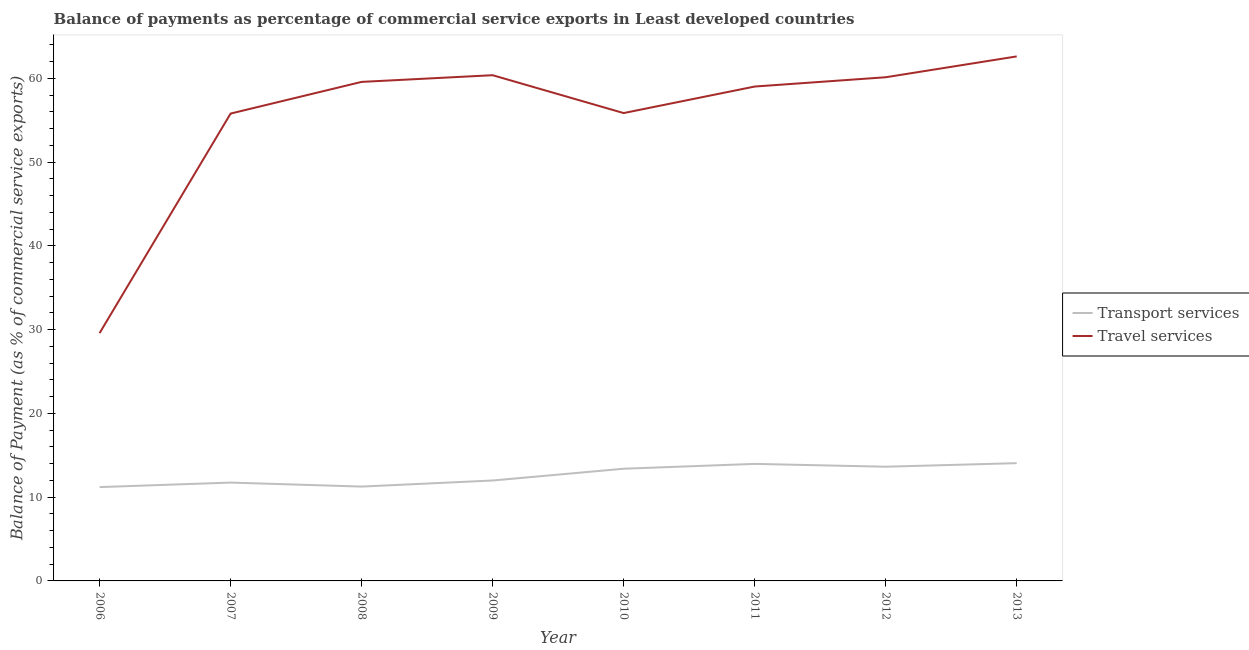Does the line corresponding to balance of payments of travel services intersect with the line corresponding to balance of payments of transport services?
Provide a short and direct response. No. Is the number of lines equal to the number of legend labels?
Your response must be concise. Yes. What is the balance of payments of transport services in 2006?
Offer a terse response. 11.2. Across all years, what is the maximum balance of payments of travel services?
Your response must be concise. 62.62. Across all years, what is the minimum balance of payments of transport services?
Make the answer very short. 11.2. In which year was the balance of payments of transport services maximum?
Provide a succinct answer. 2013. In which year was the balance of payments of transport services minimum?
Your response must be concise. 2006. What is the total balance of payments of travel services in the graph?
Provide a succinct answer. 442.94. What is the difference between the balance of payments of transport services in 2007 and that in 2012?
Provide a succinct answer. -1.89. What is the difference between the balance of payments of travel services in 2013 and the balance of payments of transport services in 2008?
Provide a short and direct response. 51.35. What is the average balance of payments of travel services per year?
Offer a very short reply. 55.37. In the year 2013, what is the difference between the balance of payments of transport services and balance of payments of travel services?
Keep it short and to the point. -48.56. In how many years, is the balance of payments of travel services greater than 8 %?
Ensure brevity in your answer.  8. What is the ratio of the balance of payments of travel services in 2006 to that in 2007?
Offer a terse response. 0.53. What is the difference between the highest and the second highest balance of payments of transport services?
Your answer should be very brief. 0.09. What is the difference between the highest and the lowest balance of payments of travel services?
Your answer should be very brief. 33.03. Is the balance of payments of transport services strictly greater than the balance of payments of travel services over the years?
Provide a short and direct response. No. What is the difference between two consecutive major ticks on the Y-axis?
Offer a terse response. 10. How many legend labels are there?
Offer a terse response. 2. How are the legend labels stacked?
Offer a very short reply. Vertical. What is the title of the graph?
Provide a short and direct response. Balance of payments as percentage of commercial service exports in Least developed countries. Does "% of gross capital formation" appear as one of the legend labels in the graph?
Ensure brevity in your answer.  No. What is the label or title of the X-axis?
Give a very brief answer. Year. What is the label or title of the Y-axis?
Provide a short and direct response. Balance of Payment (as % of commercial service exports). What is the Balance of Payment (as % of commercial service exports) of Transport services in 2006?
Give a very brief answer. 11.2. What is the Balance of Payment (as % of commercial service exports) of Travel services in 2006?
Your answer should be very brief. 29.58. What is the Balance of Payment (as % of commercial service exports) of Transport services in 2007?
Provide a succinct answer. 11.74. What is the Balance of Payment (as % of commercial service exports) in Travel services in 2007?
Your answer should be very brief. 55.79. What is the Balance of Payment (as % of commercial service exports) of Transport services in 2008?
Provide a short and direct response. 11.26. What is the Balance of Payment (as % of commercial service exports) of Travel services in 2008?
Offer a terse response. 59.57. What is the Balance of Payment (as % of commercial service exports) of Transport services in 2009?
Offer a very short reply. 11.99. What is the Balance of Payment (as % of commercial service exports) of Travel services in 2009?
Your response must be concise. 60.37. What is the Balance of Payment (as % of commercial service exports) in Transport services in 2010?
Provide a succinct answer. 13.39. What is the Balance of Payment (as % of commercial service exports) of Travel services in 2010?
Your response must be concise. 55.85. What is the Balance of Payment (as % of commercial service exports) in Transport services in 2011?
Your answer should be very brief. 13.97. What is the Balance of Payment (as % of commercial service exports) in Travel services in 2011?
Offer a terse response. 59.02. What is the Balance of Payment (as % of commercial service exports) of Transport services in 2012?
Your answer should be compact. 13.63. What is the Balance of Payment (as % of commercial service exports) of Travel services in 2012?
Give a very brief answer. 60.13. What is the Balance of Payment (as % of commercial service exports) in Transport services in 2013?
Give a very brief answer. 14.06. What is the Balance of Payment (as % of commercial service exports) in Travel services in 2013?
Ensure brevity in your answer.  62.62. Across all years, what is the maximum Balance of Payment (as % of commercial service exports) in Transport services?
Make the answer very short. 14.06. Across all years, what is the maximum Balance of Payment (as % of commercial service exports) in Travel services?
Make the answer very short. 62.62. Across all years, what is the minimum Balance of Payment (as % of commercial service exports) of Transport services?
Give a very brief answer. 11.2. Across all years, what is the minimum Balance of Payment (as % of commercial service exports) of Travel services?
Your answer should be very brief. 29.58. What is the total Balance of Payment (as % of commercial service exports) of Transport services in the graph?
Keep it short and to the point. 101.25. What is the total Balance of Payment (as % of commercial service exports) of Travel services in the graph?
Give a very brief answer. 442.94. What is the difference between the Balance of Payment (as % of commercial service exports) of Transport services in 2006 and that in 2007?
Keep it short and to the point. -0.54. What is the difference between the Balance of Payment (as % of commercial service exports) of Travel services in 2006 and that in 2007?
Ensure brevity in your answer.  -26.21. What is the difference between the Balance of Payment (as % of commercial service exports) of Transport services in 2006 and that in 2008?
Your answer should be very brief. -0.06. What is the difference between the Balance of Payment (as % of commercial service exports) of Travel services in 2006 and that in 2008?
Keep it short and to the point. -29.99. What is the difference between the Balance of Payment (as % of commercial service exports) in Transport services in 2006 and that in 2009?
Keep it short and to the point. -0.79. What is the difference between the Balance of Payment (as % of commercial service exports) in Travel services in 2006 and that in 2009?
Provide a short and direct response. -30.79. What is the difference between the Balance of Payment (as % of commercial service exports) of Transport services in 2006 and that in 2010?
Keep it short and to the point. -2.19. What is the difference between the Balance of Payment (as % of commercial service exports) in Travel services in 2006 and that in 2010?
Ensure brevity in your answer.  -26.27. What is the difference between the Balance of Payment (as % of commercial service exports) in Transport services in 2006 and that in 2011?
Provide a succinct answer. -2.77. What is the difference between the Balance of Payment (as % of commercial service exports) in Travel services in 2006 and that in 2011?
Provide a short and direct response. -29.44. What is the difference between the Balance of Payment (as % of commercial service exports) of Transport services in 2006 and that in 2012?
Ensure brevity in your answer.  -2.43. What is the difference between the Balance of Payment (as % of commercial service exports) in Travel services in 2006 and that in 2012?
Offer a very short reply. -30.55. What is the difference between the Balance of Payment (as % of commercial service exports) in Transport services in 2006 and that in 2013?
Your answer should be very brief. -2.86. What is the difference between the Balance of Payment (as % of commercial service exports) of Travel services in 2006 and that in 2013?
Give a very brief answer. -33.03. What is the difference between the Balance of Payment (as % of commercial service exports) in Transport services in 2007 and that in 2008?
Offer a very short reply. 0.48. What is the difference between the Balance of Payment (as % of commercial service exports) of Travel services in 2007 and that in 2008?
Provide a short and direct response. -3.78. What is the difference between the Balance of Payment (as % of commercial service exports) in Transport services in 2007 and that in 2009?
Your answer should be very brief. -0.25. What is the difference between the Balance of Payment (as % of commercial service exports) in Travel services in 2007 and that in 2009?
Offer a terse response. -4.58. What is the difference between the Balance of Payment (as % of commercial service exports) in Transport services in 2007 and that in 2010?
Provide a short and direct response. -1.65. What is the difference between the Balance of Payment (as % of commercial service exports) in Travel services in 2007 and that in 2010?
Offer a terse response. -0.06. What is the difference between the Balance of Payment (as % of commercial service exports) of Transport services in 2007 and that in 2011?
Make the answer very short. -2.23. What is the difference between the Balance of Payment (as % of commercial service exports) in Travel services in 2007 and that in 2011?
Ensure brevity in your answer.  -3.23. What is the difference between the Balance of Payment (as % of commercial service exports) of Transport services in 2007 and that in 2012?
Offer a very short reply. -1.89. What is the difference between the Balance of Payment (as % of commercial service exports) of Travel services in 2007 and that in 2012?
Give a very brief answer. -4.34. What is the difference between the Balance of Payment (as % of commercial service exports) in Transport services in 2007 and that in 2013?
Keep it short and to the point. -2.32. What is the difference between the Balance of Payment (as % of commercial service exports) in Travel services in 2007 and that in 2013?
Your answer should be compact. -6.82. What is the difference between the Balance of Payment (as % of commercial service exports) of Transport services in 2008 and that in 2009?
Make the answer very short. -0.73. What is the difference between the Balance of Payment (as % of commercial service exports) of Travel services in 2008 and that in 2009?
Keep it short and to the point. -0.8. What is the difference between the Balance of Payment (as % of commercial service exports) in Transport services in 2008 and that in 2010?
Keep it short and to the point. -2.13. What is the difference between the Balance of Payment (as % of commercial service exports) of Travel services in 2008 and that in 2010?
Offer a very short reply. 3.72. What is the difference between the Balance of Payment (as % of commercial service exports) in Transport services in 2008 and that in 2011?
Keep it short and to the point. -2.71. What is the difference between the Balance of Payment (as % of commercial service exports) of Travel services in 2008 and that in 2011?
Keep it short and to the point. 0.55. What is the difference between the Balance of Payment (as % of commercial service exports) of Transport services in 2008 and that in 2012?
Provide a short and direct response. -2.37. What is the difference between the Balance of Payment (as % of commercial service exports) of Travel services in 2008 and that in 2012?
Your response must be concise. -0.55. What is the difference between the Balance of Payment (as % of commercial service exports) in Transport services in 2008 and that in 2013?
Your response must be concise. -2.8. What is the difference between the Balance of Payment (as % of commercial service exports) in Travel services in 2008 and that in 2013?
Provide a succinct answer. -3.04. What is the difference between the Balance of Payment (as % of commercial service exports) of Transport services in 2009 and that in 2010?
Ensure brevity in your answer.  -1.41. What is the difference between the Balance of Payment (as % of commercial service exports) in Travel services in 2009 and that in 2010?
Offer a very short reply. 4.52. What is the difference between the Balance of Payment (as % of commercial service exports) in Transport services in 2009 and that in 2011?
Offer a terse response. -1.98. What is the difference between the Balance of Payment (as % of commercial service exports) in Travel services in 2009 and that in 2011?
Ensure brevity in your answer.  1.35. What is the difference between the Balance of Payment (as % of commercial service exports) in Transport services in 2009 and that in 2012?
Your answer should be compact. -1.65. What is the difference between the Balance of Payment (as % of commercial service exports) of Travel services in 2009 and that in 2012?
Your response must be concise. 0.24. What is the difference between the Balance of Payment (as % of commercial service exports) of Transport services in 2009 and that in 2013?
Offer a very short reply. -2.07. What is the difference between the Balance of Payment (as % of commercial service exports) in Travel services in 2009 and that in 2013?
Your answer should be compact. -2.24. What is the difference between the Balance of Payment (as % of commercial service exports) in Transport services in 2010 and that in 2011?
Keep it short and to the point. -0.58. What is the difference between the Balance of Payment (as % of commercial service exports) in Travel services in 2010 and that in 2011?
Your answer should be compact. -3.17. What is the difference between the Balance of Payment (as % of commercial service exports) of Transport services in 2010 and that in 2012?
Provide a short and direct response. -0.24. What is the difference between the Balance of Payment (as % of commercial service exports) in Travel services in 2010 and that in 2012?
Give a very brief answer. -4.28. What is the difference between the Balance of Payment (as % of commercial service exports) of Transport services in 2010 and that in 2013?
Your answer should be compact. -0.66. What is the difference between the Balance of Payment (as % of commercial service exports) of Travel services in 2010 and that in 2013?
Your answer should be very brief. -6.76. What is the difference between the Balance of Payment (as % of commercial service exports) of Transport services in 2011 and that in 2012?
Ensure brevity in your answer.  0.34. What is the difference between the Balance of Payment (as % of commercial service exports) of Travel services in 2011 and that in 2012?
Make the answer very short. -1.11. What is the difference between the Balance of Payment (as % of commercial service exports) in Transport services in 2011 and that in 2013?
Your answer should be compact. -0.09. What is the difference between the Balance of Payment (as % of commercial service exports) of Travel services in 2011 and that in 2013?
Offer a terse response. -3.6. What is the difference between the Balance of Payment (as % of commercial service exports) of Transport services in 2012 and that in 2013?
Give a very brief answer. -0.42. What is the difference between the Balance of Payment (as % of commercial service exports) in Travel services in 2012 and that in 2013?
Keep it short and to the point. -2.49. What is the difference between the Balance of Payment (as % of commercial service exports) in Transport services in 2006 and the Balance of Payment (as % of commercial service exports) in Travel services in 2007?
Your response must be concise. -44.59. What is the difference between the Balance of Payment (as % of commercial service exports) of Transport services in 2006 and the Balance of Payment (as % of commercial service exports) of Travel services in 2008?
Offer a very short reply. -48.37. What is the difference between the Balance of Payment (as % of commercial service exports) in Transport services in 2006 and the Balance of Payment (as % of commercial service exports) in Travel services in 2009?
Your answer should be compact. -49.17. What is the difference between the Balance of Payment (as % of commercial service exports) of Transport services in 2006 and the Balance of Payment (as % of commercial service exports) of Travel services in 2010?
Your answer should be very brief. -44.65. What is the difference between the Balance of Payment (as % of commercial service exports) in Transport services in 2006 and the Balance of Payment (as % of commercial service exports) in Travel services in 2011?
Your answer should be very brief. -47.82. What is the difference between the Balance of Payment (as % of commercial service exports) of Transport services in 2006 and the Balance of Payment (as % of commercial service exports) of Travel services in 2012?
Your response must be concise. -48.93. What is the difference between the Balance of Payment (as % of commercial service exports) of Transport services in 2006 and the Balance of Payment (as % of commercial service exports) of Travel services in 2013?
Provide a succinct answer. -51.42. What is the difference between the Balance of Payment (as % of commercial service exports) of Transport services in 2007 and the Balance of Payment (as % of commercial service exports) of Travel services in 2008?
Your answer should be compact. -47.83. What is the difference between the Balance of Payment (as % of commercial service exports) in Transport services in 2007 and the Balance of Payment (as % of commercial service exports) in Travel services in 2009?
Ensure brevity in your answer.  -48.63. What is the difference between the Balance of Payment (as % of commercial service exports) of Transport services in 2007 and the Balance of Payment (as % of commercial service exports) of Travel services in 2010?
Offer a very short reply. -44.11. What is the difference between the Balance of Payment (as % of commercial service exports) in Transport services in 2007 and the Balance of Payment (as % of commercial service exports) in Travel services in 2011?
Your answer should be very brief. -47.28. What is the difference between the Balance of Payment (as % of commercial service exports) of Transport services in 2007 and the Balance of Payment (as % of commercial service exports) of Travel services in 2012?
Your answer should be very brief. -48.39. What is the difference between the Balance of Payment (as % of commercial service exports) of Transport services in 2007 and the Balance of Payment (as % of commercial service exports) of Travel services in 2013?
Ensure brevity in your answer.  -50.88. What is the difference between the Balance of Payment (as % of commercial service exports) of Transport services in 2008 and the Balance of Payment (as % of commercial service exports) of Travel services in 2009?
Offer a very short reply. -49.11. What is the difference between the Balance of Payment (as % of commercial service exports) in Transport services in 2008 and the Balance of Payment (as % of commercial service exports) in Travel services in 2010?
Provide a short and direct response. -44.59. What is the difference between the Balance of Payment (as % of commercial service exports) in Transport services in 2008 and the Balance of Payment (as % of commercial service exports) in Travel services in 2011?
Your answer should be compact. -47.76. What is the difference between the Balance of Payment (as % of commercial service exports) in Transport services in 2008 and the Balance of Payment (as % of commercial service exports) in Travel services in 2012?
Provide a succinct answer. -48.87. What is the difference between the Balance of Payment (as % of commercial service exports) in Transport services in 2008 and the Balance of Payment (as % of commercial service exports) in Travel services in 2013?
Offer a terse response. -51.35. What is the difference between the Balance of Payment (as % of commercial service exports) in Transport services in 2009 and the Balance of Payment (as % of commercial service exports) in Travel services in 2010?
Your answer should be very brief. -43.86. What is the difference between the Balance of Payment (as % of commercial service exports) of Transport services in 2009 and the Balance of Payment (as % of commercial service exports) of Travel services in 2011?
Ensure brevity in your answer.  -47.03. What is the difference between the Balance of Payment (as % of commercial service exports) in Transport services in 2009 and the Balance of Payment (as % of commercial service exports) in Travel services in 2012?
Your response must be concise. -48.14. What is the difference between the Balance of Payment (as % of commercial service exports) in Transport services in 2009 and the Balance of Payment (as % of commercial service exports) in Travel services in 2013?
Your response must be concise. -50.63. What is the difference between the Balance of Payment (as % of commercial service exports) of Transport services in 2010 and the Balance of Payment (as % of commercial service exports) of Travel services in 2011?
Your answer should be very brief. -45.63. What is the difference between the Balance of Payment (as % of commercial service exports) of Transport services in 2010 and the Balance of Payment (as % of commercial service exports) of Travel services in 2012?
Ensure brevity in your answer.  -46.73. What is the difference between the Balance of Payment (as % of commercial service exports) of Transport services in 2010 and the Balance of Payment (as % of commercial service exports) of Travel services in 2013?
Provide a succinct answer. -49.22. What is the difference between the Balance of Payment (as % of commercial service exports) in Transport services in 2011 and the Balance of Payment (as % of commercial service exports) in Travel services in 2012?
Your response must be concise. -46.16. What is the difference between the Balance of Payment (as % of commercial service exports) of Transport services in 2011 and the Balance of Payment (as % of commercial service exports) of Travel services in 2013?
Your answer should be very brief. -48.65. What is the difference between the Balance of Payment (as % of commercial service exports) in Transport services in 2012 and the Balance of Payment (as % of commercial service exports) in Travel services in 2013?
Ensure brevity in your answer.  -48.98. What is the average Balance of Payment (as % of commercial service exports) of Transport services per year?
Your response must be concise. 12.66. What is the average Balance of Payment (as % of commercial service exports) in Travel services per year?
Ensure brevity in your answer.  55.37. In the year 2006, what is the difference between the Balance of Payment (as % of commercial service exports) of Transport services and Balance of Payment (as % of commercial service exports) of Travel services?
Your answer should be very brief. -18.38. In the year 2007, what is the difference between the Balance of Payment (as % of commercial service exports) in Transport services and Balance of Payment (as % of commercial service exports) in Travel services?
Give a very brief answer. -44.05. In the year 2008, what is the difference between the Balance of Payment (as % of commercial service exports) of Transport services and Balance of Payment (as % of commercial service exports) of Travel services?
Your answer should be compact. -48.31. In the year 2009, what is the difference between the Balance of Payment (as % of commercial service exports) of Transport services and Balance of Payment (as % of commercial service exports) of Travel services?
Keep it short and to the point. -48.38. In the year 2010, what is the difference between the Balance of Payment (as % of commercial service exports) in Transport services and Balance of Payment (as % of commercial service exports) in Travel services?
Provide a short and direct response. -42.46. In the year 2011, what is the difference between the Balance of Payment (as % of commercial service exports) in Transport services and Balance of Payment (as % of commercial service exports) in Travel services?
Give a very brief answer. -45.05. In the year 2012, what is the difference between the Balance of Payment (as % of commercial service exports) in Transport services and Balance of Payment (as % of commercial service exports) in Travel services?
Provide a short and direct response. -46.49. In the year 2013, what is the difference between the Balance of Payment (as % of commercial service exports) in Transport services and Balance of Payment (as % of commercial service exports) in Travel services?
Your answer should be very brief. -48.56. What is the ratio of the Balance of Payment (as % of commercial service exports) in Transport services in 2006 to that in 2007?
Your answer should be compact. 0.95. What is the ratio of the Balance of Payment (as % of commercial service exports) in Travel services in 2006 to that in 2007?
Ensure brevity in your answer.  0.53. What is the ratio of the Balance of Payment (as % of commercial service exports) in Transport services in 2006 to that in 2008?
Keep it short and to the point. 0.99. What is the ratio of the Balance of Payment (as % of commercial service exports) of Travel services in 2006 to that in 2008?
Keep it short and to the point. 0.5. What is the ratio of the Balance of Payment (as % of commercial service exports) of Transport services in 2006 to that in 2009?
Offer a very short reply. 0.93. What is the ratio of the Balance of Payment (as % of commercial service exports) of Travel services in 2006 to that in 2009?
Your response must be concise. 0.49. What is the ratio of the Balance of Payment (as % of commercial service exports) of Transport services in 2006 to that in 2010?
Make the answer very short. 0.84. What is the ratio of the Balance of Payment (as % of commercial service exports) of Travel services in 2006 to that in 2010?
Offer a very short reply. 0.53. What is the ratio of the Balance of Payment (as % of commercial service exports) of Transport services in 2006 to that in 2011?
Give a very brief answer. 0.8. What is the ratio of the Balance of Payment (as % of commercial service exports) in Travel services in 2006 to that in 2011?
Make the answer very short. 0.5. What is the ratio of the Balance of Payment (as % of commercial service exports) of Transport services in 2006 to that in 2012?
Your answer should be very brief. 0.82. What is the ratio of the Balance of Payment (as % of commercial service exports) of Travel services in 2006 to that in 2012?
Offer a terse response. 0.49. What is the ratio of the Balance of Payment (as % of commercial service exports) of Transport services in 2006 to that in 2013?
Keep it short and to the point. 0.8. What is the ratio of the Balance of Payment (as % of commercial service exports) in Travel services in 2006 to that in 2013?
Make the answer very short. 0.47. What is the ratio of the Balance of Payment (as % of commercial service exports) in Transport services in 2007 to that in 2008?
Provide a succinct answer. 1.04. What is the ratio of the Balance of Payment (as % of commercial service exports) in Travel services in 2007 to that in 2008?
Your answer should be very brief. 0.94. What is the ratio of the Balance of Payment (as % of commercial service exports) of Transport services in 2007 to that in 2009?
Provide a short and direct response. 0.98. What is the ratio of the Balance of Payment (as % of commercial service exports) in Travel services in 2007 to that in 2009?
Your answer should be compact. 0.92. What is the ratio of the Balance of Payment (as % of commercial service exports) of Transport services in 2007 to that in 2010?
Your answer should be very brief. 0.88. What is the ratio of the Balance of Payment (as % of commercial service exports) of Transport services in 2007 to that in 2011?
Your response must be concise. 0.84. What is the ratio of the Balance of Payment (as % of commercial service exports) in Travel services in 2007 to that in 2011?
Offer a terse response. 0.95. What is the ratio of the Balance of Payment (as % of commercial service exports) of Transport services in 2007 to that in 2012?
Your answer should be very brief. 0.86. What is the ratio of the Balance of Payment (as % of commercial service exports) in Travel services in 2007 to that in 2012?
Offer a very short reply. 0.93. What is the ratio of the Balance of Payment (as % of commercial service exports) of Transport services in 2007 to that in 2013?
Offer a very short reply. 0.84. What is the ratio of the Balance of Payment (as % of commercial service exports) of Travel services in 2007 to that in 2013?
Keep it short and to the point. 0.89. What is the ratio of the Balance of Payment (as % of commercial service exports) in Transport services in 2008 to that in 2009?
Your answer should be compact. 0.94. What is the ratio of the Balance of Payment (as % of commercial service exports) of Transport services in 2008 to that in 2010?
Ensure brevity in your answer.  0.84. What is the ratio of the Balance of Payment (as % of commercial service exports) in Travel services in 2008 to that in 2010?
Give a very brief answer. 1.07. What is the ratio of the Balance of Payment (as % of commercial service exports) in Transport services in 2008 to that in 2011?
Keep it short and to the point. 0.81. What is the ratio of the Balance of Payment (as % of commercial service exports) of Travel services in 2008 to that in 2011?
Make the answer very short. 1.01. What is the ratio of the Balance of Payment (as % of commercial service exports) of Transport services in 2008 to that in 2012?
Give a very brief answer. 0.83. What is the ratio of the Balance of Payment (as % of commercial service exports) of Travel services in 2008 to that in 2012?
Provide a succinct answer. 0.99. What is the ratio of the Balance of Payment (as % of commercial service exports) in Transport services in 2008 to that in 2013?
Ensure brevity in your answer.  0.8. What is the ratio of the Balance of Payment (as % of commercial service exports) of Travel services in 2008 to that in 2013?
Offer a very short reply. 0.95. What is the ratio of the Balance of Payment (as % of commercial service exports) in Transport services in 2009 to that in 2010?
Your answer should be very brief. 0.9. What is the ratio of the Balance of Payment (as % of commercial service exports) of Travel services in 2009 to that in 2010?
Provide a short and direct response. 1.08. What is the ratio of the Balance of Payment (as % of commercial service exports) of Transport services in 2009 to that in 2011?
Keep it short and to the point. 0.86. What is the ratio of the Balance of Payment (as % of commercial service exports) in Travel services in 2009 to that in 2011?
Your response must be concise. 1.02. What is the ratio of the Balance of Payment (as % of commercial service exports) of Transport services in 2009 to that in 2012?
Your response must be concise. 0.88. What is the ratio of the Balance of Payment (as % of commercial service exports) of Travel services in 2009 to that in 2012?
Your answer should be compact. 1. What is the ratio of the Balance of Payment (as % of commercial service exports) in Transport services in 2009 to that in 2013?
Ensure brevity in your answer.  0.85. What is the ratio of the Balance of Payment (as % of commercial service exports) of Travel services in 2009 to that in 2013?
Your answer should be compact. 0.96. What is the ratio of the Balance of Payment (as % of commercial service exports) in Transport services in 2010 to that in 2011?
Keep it short and to the point. 0.96. What is the ratio of the Balance of Payment (as % of commercial service exports) in Travel services in 2010 to that in 2011?
Provide a succinct answer. 0.95. What is the ratio of the Balance of Payment (as % of commercial service exports) in Transport services in 2010 to that in 2012?
Provide a succinct answer. 0.98. What is the ratio of the Balance of Payment (as % of commercial service exports) in Travel services in 2010 to that in 2012?
Give a very brief answer. 0.93. What is the ratio of the Balance of Payment (as % of commercial service exports) of Transport services in 2010 to that in 2013?
Give a very brief answer. 0.95. What is the ratio of the Balance of Payment (as % of commercial service exports) of Travel services in 2010 to that in 2013?
Keep it short and to the point. 0.89. What is the ratio of the Balance of Payment (as % of commercial service exports) in Transport services in 2011 to that in 2012?
Ensure brevity in your answer.  1.02. What is the ratio of the Balance of Payment (as % of commercial service exports) of Travel services in 2011 to that in 2012?
Your response must be concise. 0.98. What is the ratio of the Balance of Payment (as % of commercial service exports) in Travel services in 2011 to that in 2013?
Your answer should be very brief. 0.94. What is the ratio of the Balance of Payment (as % of commercial service exports) of Transport services in 2012 to that in 2013?
Make the answer very short. 0.97. What is the ratio of the Balance of Payment (as % of commercial service exports) in Travel services in 2012 to that in 2013?
Keep it short and to the point. 0.96. What is the difference between the highest and the second highest Balance of Payment (as % of commercial service exports) in Transport services?
Give a very brief answer. 0.09. What is the difference between the highest and the second highest Balance of Payment (as % of commercial service exports) in Travel services?
Ensure brevity in your answer.  2.24. What is the difference between the highest and the lowest Balance of Payment (as % of commercial service exports) of Transport services?
Keep it short and to the point. 2.86. What is the difference between the highest and the lowest Balance of Payment (as % of commercial service exports) in Travel services?
Keep it short and to the point. 33.03. 